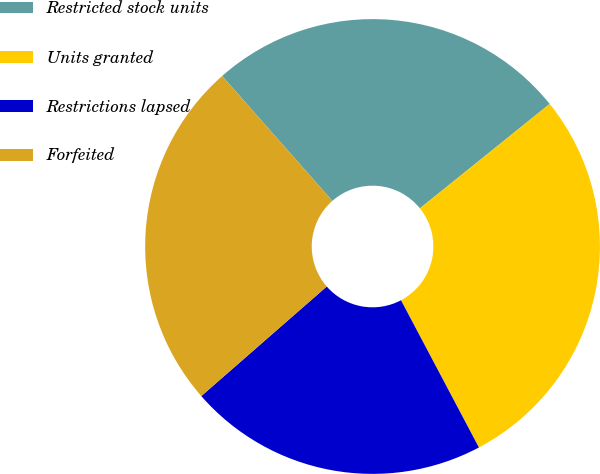Convert chart. <chart><loc_0><loc_0><loc_500><loc_500><pie_chart><fcel>Restricted stock units<fcel>Units granted<fcel>Restrictions lapsed<fcel>Forfeited<nl><fcel>25.72%<fcel>28.04%<fcel>21.32%<fcel>24.92%<nl></chart> 